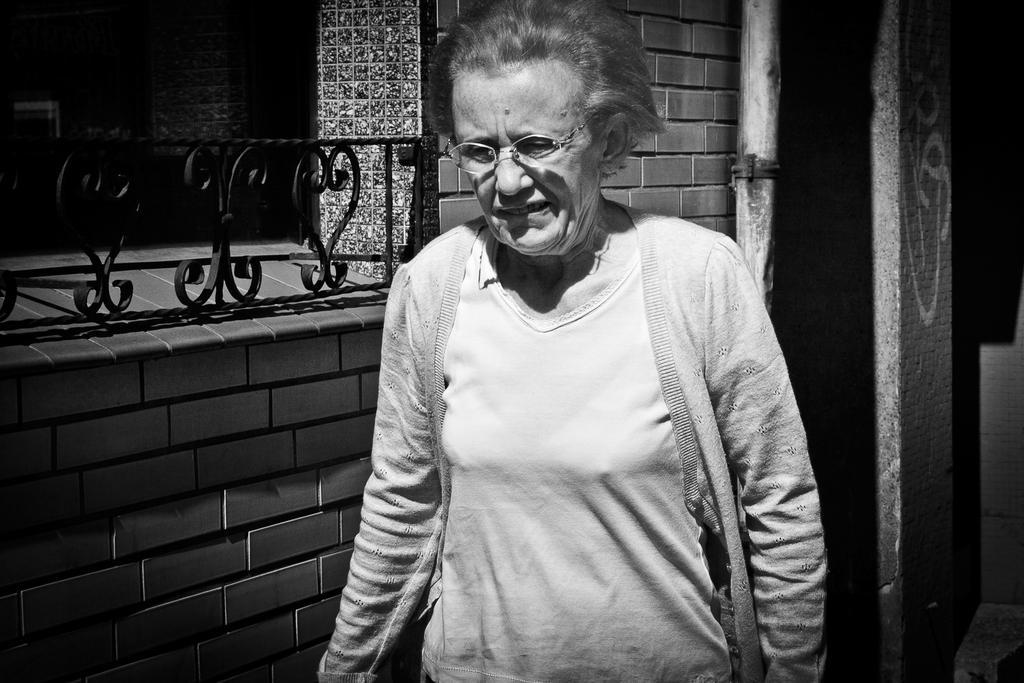In one or two sentences, can you explain what this image depicts? The picture is in Black and white we can see an old woman wearing a shirt with jacket and has spectacles. On the left side, we can see a brick wall with black color grills. 